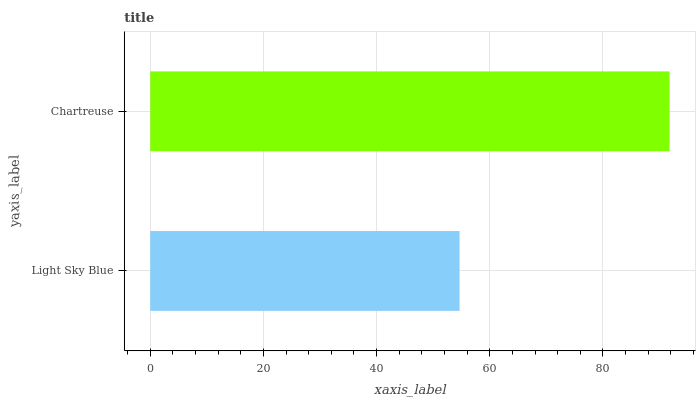Is Light Sky Blue the minimum?
Answer yes or no. Yes. Is Chartreuse the maximum?
Answer yes or no. Yes. Is Chartreuse the minimum?
Answer yes or no. No. Is Chartreuse greater than Light Sky Blue?
Answer yes or no. Yes. Is Light Sky Blue less than Chartreuse?
Answer yes or no. Yes. Is Light Sky Blue greater than Chartreuse?
Answer yes or no. No. Is Chartreuse less than Light Sky Blue?
Answer yes or no. No. Is Chartreuse the high median?
Answer yes or no. Yes. Is Light Sky Blue the low median?
Answer yes or no. Yes. Is Light Sky Blue the high median?
Answer yes or no. No. Is Chartreuse the low median?
Answer yes or no. No. 